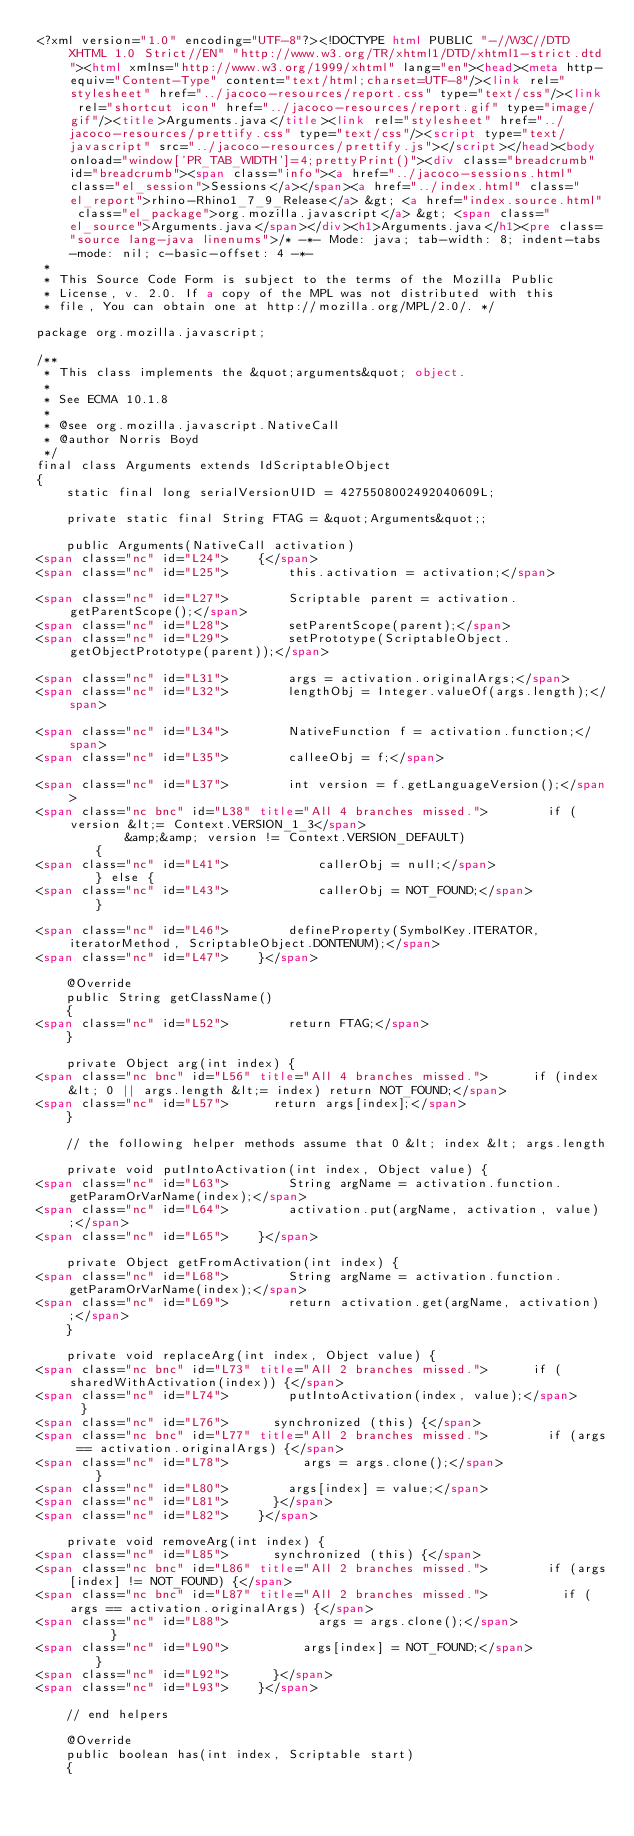<code> <loc_0><loc_0><loc_500><loc_500><_HTML_><?xml version="1.0" encoding="UTF-8"?><!DOCTYPE html PUBLIC "-//W3C//DTD XHTML 1.0 Strict//EN" "http://www.w3.org/TR/xhtml1/DTD/xhtml1-strict.dtd"><html xmlns="http://www.w3.org/1999/xhtml" lang="en"><head><meta http-equiv="Content-Type" content="text/html;charset=UTF-8"/><link rel="stylesheet" href="../jacoco-resources/report.css" type="text/css"/><link rel="shortcut icon" href="../jacoco-resources/report.gif" type="image/gif"/><title>Arguments.java</title><link rel="stylesheet" href="../jacoco-resources/prettify.css" type="text/css"/><script type="text/javascript" src="../jacoco-resources/prettify.js"></script></head><body onload="window['PR_TAB_WIDTH']=4;prettyPrint()"><div class="breadcrumb" id="breadcrumb"><span class="info"><a href="../jacoco-sessions.html" class="el_session">Sessions</a></span><a href="../index.html" class="el_report">rhino-Rhino1_7_9_Release</a> &gt; <a href="index.source.html" class="el_package">org.mozilla.javascript</a> &gt; <span class="el_source">Arguments.java</span></div><h1>Arguments.java</h1><pre class="source lang-java linenums">/* -*- Mode: java; tab-width: 8; indent-tabs-mode: nil; c-basic-offset: 4 -*-
 *
 * This Source Code Form is subject to the terms of the Mozilla Public
 * License, v. 2.0. If a copy of the MPL was not distributed with this
 * file, You can obtain one at http://mozilla.org/MPL/2.0/. */

package org.mozilla.javascript;

/**
 * This class implements the &quot;arguments&quot; object.
 *
 * See ECMA 10.1.8
 *
 * @see org.mozilla.javascript.NativeCall
 * @author Norris Boyd
 */
final class Arguments extends IdScriptableObject
{
    static final long serialVersionUID = 4275508002492040609L;

    private static final String FTAG = &quot;Arguments&quot;;

    public Arguments(NativeCall activation)
<span class="nc" id="L24">    {</span>
<span class="nc" id="L25">        this.activation = activation;</span>

<span class="nc" id="L27">        Scriptable parent = activation.getParentScope();</span>
<span class="nc" id="L28">        setParentScope(parent);</span>
<span class="nc" id="L29">        setPrototype(ScriptableObject.getObjectPrototype(parent));</span>

<span class="nc" id="L31">        args = activation.originalArgs;</span>
<span class="nc" id="L32">        lengthObj = Integer.valueOf(args.length);</span>

<span class="nc" id="L34">        NativeFunction f = activation.function;</span>
<span class="nc" id="L35">        calleeObj = f;</span>

<span class="nc" id="L37">        int version = f.getLanguageVersion();</span>
<span class="nc bnc" id="L38" title="All 4 branches missed.">        if (version &lt;= Context.VERSION_1_3</span>
            &amp;&amp; version != Context.VERSION_DEFAULT)
        {
<span class="nc" id="L41">            callerObj = null;</span>
        } else {
<span class="nc" id="L43">            callerObj = NOT_FOUND;</span>
        }

<span class="nc" id="L46">        defineProperty(SymbolKey.ITERATOR, iteratorMethod, ScriptableObject.DONTENUM);</span>
<span class="nc" id="L47">    }</span>

    @Override
    public String getClassName()
    {
<span class="nc" id="L52">        return FTAG;</span>
    }

    private Object arg(int index) {
<span class="nc bnc" id="L56" title="All 4 branches missed.">      if (index &lt; 0 || args.length &lt;= index) return NOT_FOUND;</span>
<span class="nc" id="L57">      return args[index];</span>
    }

    // the following helper methods assume that 0 &lt; index &lt; args.length

    private void putIntoActivation(int index, Object value) {
<span class="nc" id="L63">        String argName = activation.function.getParamOrVarName(index);</span>
<span class="nc" id="L64">        activation.put(argName, activation, value);</span>
<span class="nc" id="L65">    }</span>

    private Object getFromActivation(int index) {
<span class="nc" id="L68">        String argName = activation.function.getParamOrVarName(index);</span>
<span class="nc" id="L69">        return activation.get(argName, activation);</span>
    }

    private void replaceArg(int index, Object value) {
<span class="nc bnc" id="L73" title="All 2 branches missed.">      if (sharedWithActivation(index)) {</span>
<span class="nc" id="L74">        putIntoActivation(index, value);</span>
      }
<span class="nc" id="L76">      synchronized (this) {</span>
<span class="nc bnc" id="L77" title="All 2 branches missed.">        if (args == activation.originalArgs) {</span>
<span class="nc" id="L78">          args = args.clone();</span>
        }
<span class="nc" id="L80">        args[index] = value;</span>
<span class="nc" id="L81">      }</span>
<span class="nc" id="L82">    }</span>

    private void removeArg(int index) {
<span class="nc" id="L85">      synchronized (this) {</span>
<span class="nc bnc" id="L86" title="All 2 branches missed.">        if (args[index] != NOT_FOUND) {</span>
<span class="nc bnc" id="L87" title="All 2 branches missed.">          if (args == activation.originalArgs) {</span>
<span class="nc" id="L88">            args = args.clone();</span>
          }
<span class="nc" id="L90">          args[index] = NOT_FOUND;</span>
        }
<span class="nc" id="L92">      }</span>
<span class="nc" id="L93">    }</span>

    // end helpers

    @Override
    public boolean has(int index, Scriptable start)
    {</code> 